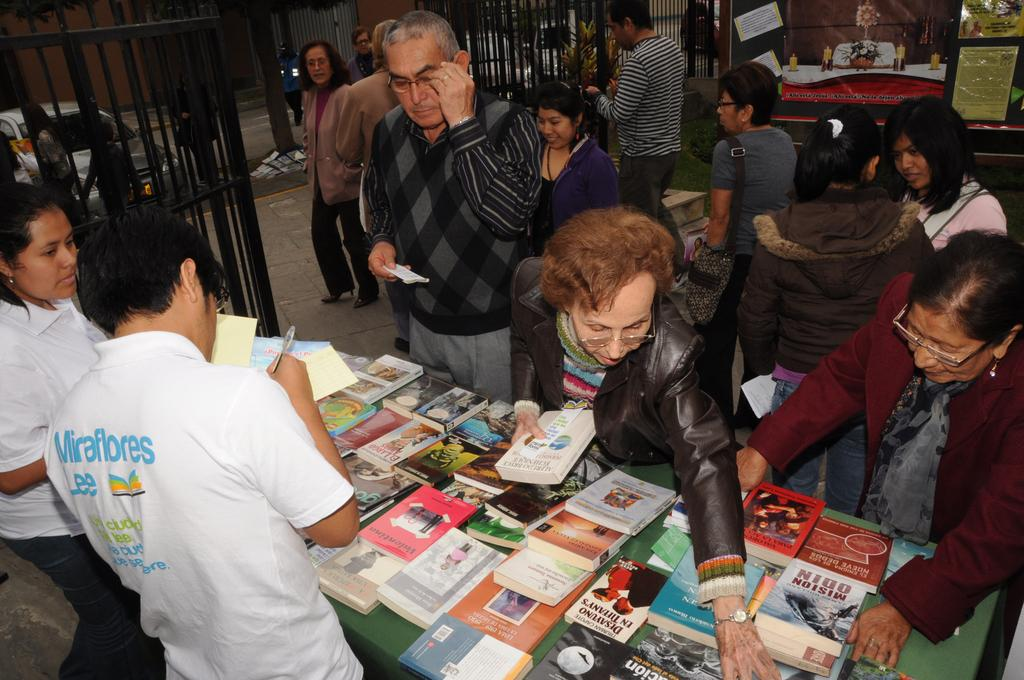<image>
Describe the image concisely. People look at books on a table and a man wearing a Miraflores shirt writes on a note card. 